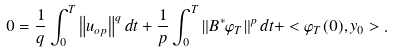Convert formula to latex. <formula><loc_0><loc_0><loc_500><loc_500>0 = \frac { 1 } { q } \int _ { 0 } ^ { T } { \left \| { u _ { o p } } \right \| ^ { q } d t } + \frac { 1 } { p } \int _ { 0 } ^ { T } { \left \| { B ^ { * } \varphi _ { T } } \right \| ^ { p } d t } + < \varphi _ { T } ( 0 ) , y _ { 0 } > .</formula> 